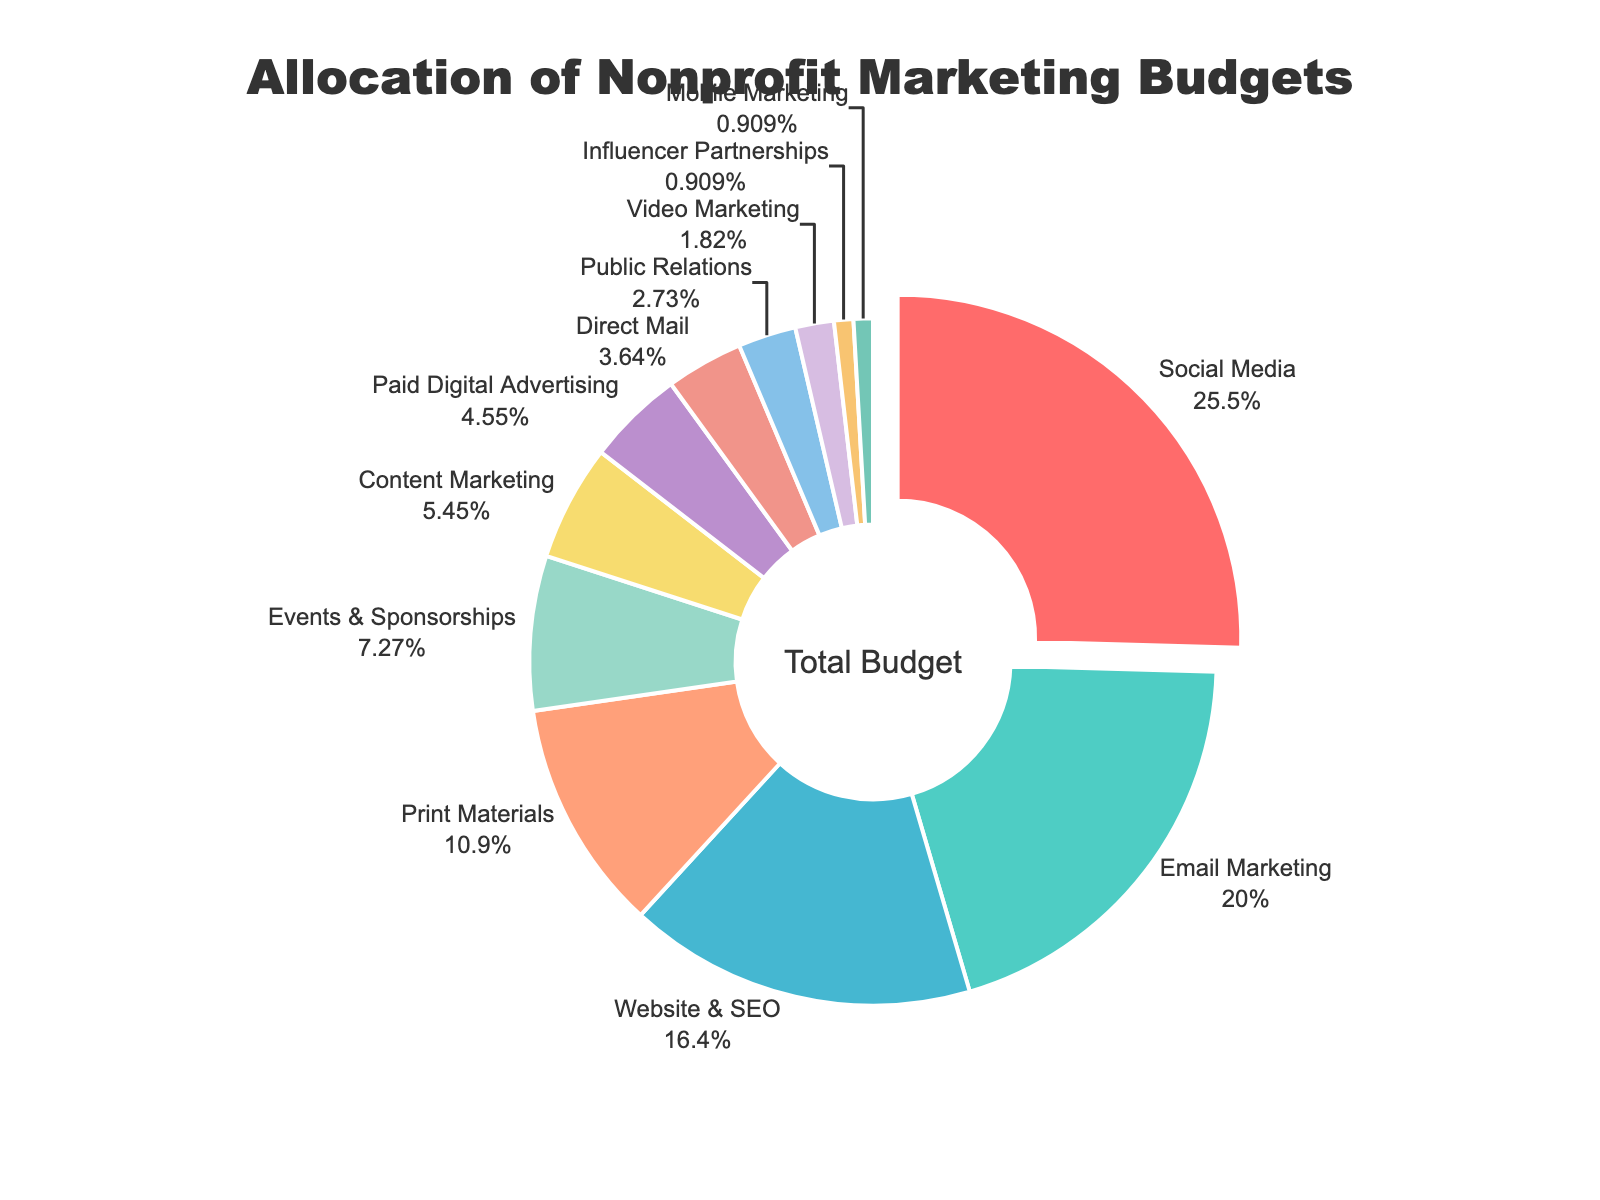Which channel has the largest percentage of the budget? The largest segment on the pie chart is the one labeled "Social Media." The percentage value for this segment is 28%.
Answer: Social Media Which channel has the smallest budget allocation? The smallest segments on the pie chart are "Influencer Partnerships" and "Mobile Marketing," each labeled with a percentage value of 1%.
Answer: Influencer Partnerships and Mobile Marketing What is the combined budget percentage for Social Media and Email Marketing? The percentage for Social Media is 28% and for Email Marketing is 22%. Adding these together gives 28% + 22% = 50%.
Answer: 50% Is the combined budget allocation for Website & SEO and Print Materials greater than that for Events & Sponsorships, Content Marketing, and Paid Digital Advertising combined? The percentages for Website & SEO and Print Materials are 18% and 12%, respectively, which together total 30%. The percentages for Events & Sponsorships, Content Marketing, and Paid Digital Advertising are 8%, 6%, and 5%, respectively, which together total 19%. Therefore, 30% is greater than 19%.
Answer: Yes Which channels have a budget allocation greater than or equal to 10%? The segments labeled "Social Media" (28%), "Email Marketing" (22%), "Website & SEO" (18%), and "Print Materials" (12%) each have a budget allocation greater than or equal to 10%.
Answer: Social Media, Email Marketing, Website & SEO, and Print Materials What is the difference in budget allocation between Content Marketing and Video Marketing? The percentage for Content Marketing is 6% and for Video Marketing is 2%. The difference is 6% - 2% = 4%.
Answer: 4% Which segments have the same color, and what is the shared hue? Without specifying exact hex codes or RGB values, we can say that no two segments should have exactly the same color due to the custom palette used, making each segment visually distinct. However, similar hues can be observed, like shades of the same color family.
Answer: None (each has a unique color) What percentage of the budget is allocated to channels other than Social Media, Email Marketing, and Website & SEO? The total budget for all channels combined is 100%. The percentages for Social Media, Email Marketing, and Website & SEO are 28%, 22%, and 18%, respectively. Summing these gives 28% + 22% + 18% = 68%. Subtracting this from 100% gives 100% - 68% = 32%.
Answer: 32% How does the budget allocation for Direct Mail compare to Public Relations? The segment for Direct Mail is labeled with a percentage of 4%, and the segment for Public Relations is labeled with a percentage of 3%. Thus, Direct Mail has a higher percentage than Public Relations.
Answer: Direct Mail > Public Relations 